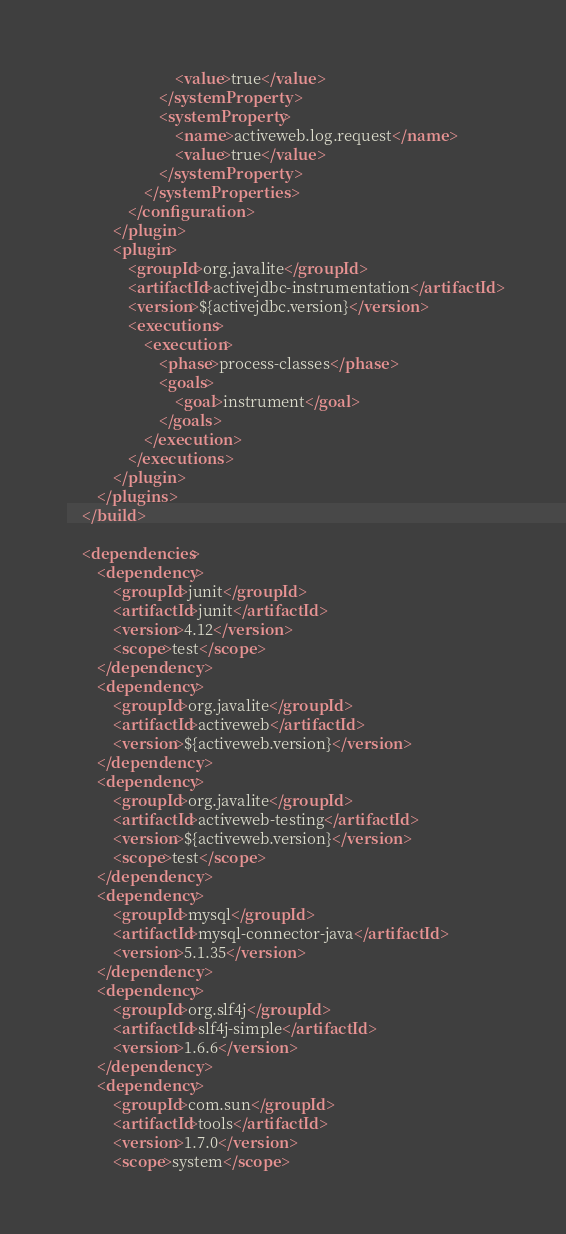Convert code to text. <code><loc_0><loc_0><loc_500><loc_500><_XML_>                            <value>true</value>
                        </systemProperty>
                        <systemProperty>
                            <name>activeweb.log.request</name>
                            <value>true</value>
                        </systemProperty>
                    </systemProperties>
                </configuration>
            </plugin>
            <plugin>
                <groupId>org.javalite</groupId>
                <artifactId>activejdbc-instrumentation</artifactId>
                <version>${activejdbc.version}</version>
                <executions>
                    <execution>
                        <phase>process-classes</phase>
                        <goals>
                            <goal>instrument</goal>
                        </goals>
                    </execution>
                </executions>
            </plugin>
        </plugins>
    </build>

    <dependencies>
        <dependency>
            <groupId>junit</groupId>
            <artifactId>junit</artifactId>
            <version>4.12</version>
            <scope>test</scope>
        </dependency>
        <dependency>
            <groupId>org.javalite</groupId>
            <artifactId>activeweb</artifactId>
            <version>${activeweb.version}</version>
        </dependency>
        <dependency>
            <groupId>org.javalite</groupId>
            <artifactId>activeweb-testing</artifactId>
            <version>${activeweb.version}</version>
            <scope>test</scope>
        </dependency>
        <dependency>
            <groupId>mysql</groupId>
            <artifactId>mysql-connector-java</artifactId>
            <version>5.1.35</version>
        </dependency>
        <dependency>
            <groupId>org.slf4j</groupId>
            <artifactId>slf4j-simple</artifactId>
            <version>1.6.6</version>
        </dependency>
        <dependency>
            <groupId>com.sun</groupId>
            <artifactId>tools</artifactId>
            <version>1.7.0</version>
            <scope>system</scope></code> 